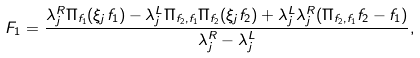Convert formula to latex. <formula><loc_0><loc_0><loc_500><loc_500>F _ { 1 } = \frac { \lambda _ { j } ^ { R } \Pi _ { f _ { 1 } } ( \xi _ { j } f _ { 1 } ) - \lambda _ { j } ^ { L } \Pi _ { f _ { 2 } , f _ { 1 } } \Pi _ { f _ { 2 } } ( \xi _ { j } f _ { 2 } ) + \lambda _ { j } ^ { L } \lambda _ { j } ^ { R } ( \Pi _ { f _ { 2 } , f _ { 1 } } f _ { 2 } - f _ { 1 } ) } { \lambda _ { j } ^ { R } - \lambda _ { j } ^ { L } } ,</formula> 